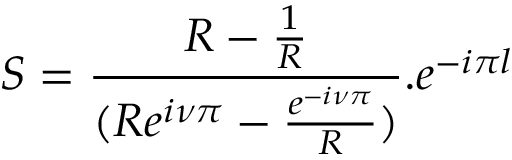Convert formula to latex. <formula><loc_0><loc_0><loc_500><loc_500>S = \frac { R - \frac { 1 } { R } } { ( R e ^ { i \nu \pi } - \frac { e ^ { - i \nu \pi } } { R } ) } . e ^ { - i \pi l }</formula> 